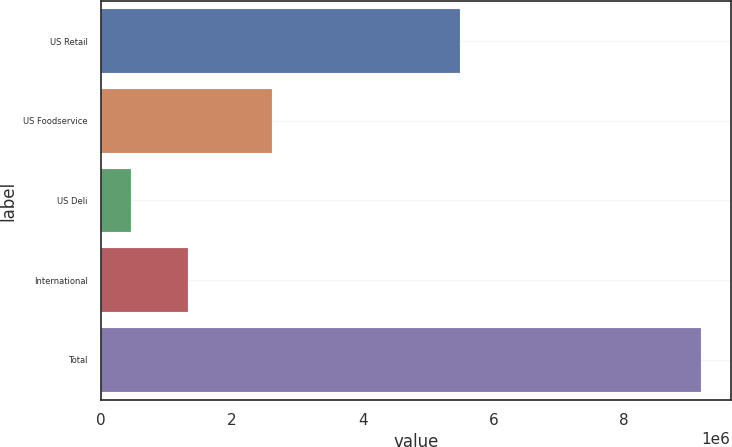<chart> <loc_0><loc_0><loc_500><loc_500><bar_chart><fcel>US Retail<fcel>US Foodservice<fcel>US Deli<fcel>International<fcel>Total<nl><fcel>5.49282e+06<fcel>2.61122e+06<fcel>460250<fcel>1.33098e+06<fcel>9.16752e+06<nl></chart> 